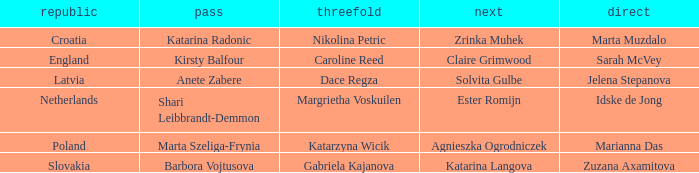Which Lead has Katarina Radonic as Skip? Marta Muzdalo. 